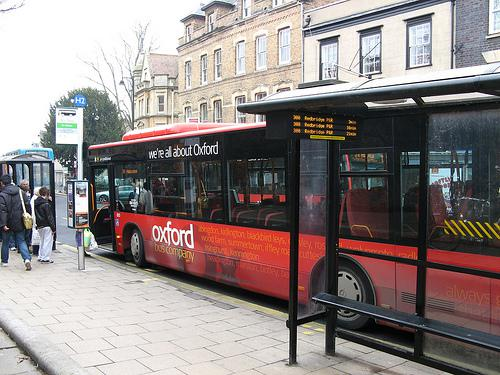Question: where was the photo taken?
Choices:
A. In the city.
B. On a city street.
C. Downtown.
D. At an intersection.
Answer with the letter. Answer: B Question: what type of shelters are shown on the sidewalk?
Choices:
A. Homeless shelters.
B. Street vendor set ups.
C. Bus shelters.
D. No other plausible answer.
Answer with the letter. Answer: C Question: what does the bus stop sign say in a blue circle?
Choices:
A. Stop.
B. Caution.
C. H2.
D. Stay back.
Answer with the letter. Answer: C 